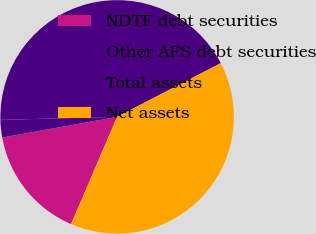Convert chart. <chart><loc_0><loc_0><loc_500><loc_500><pie_chart><fcel>NDTF debt securities<fcel>Other AFS debt securities<fcel>Total assets<fcel>Net assets<nl><fcel>15.71%<fcel>2.42%<fcel>42.8%<fcel>39.07%<nl></chart> 